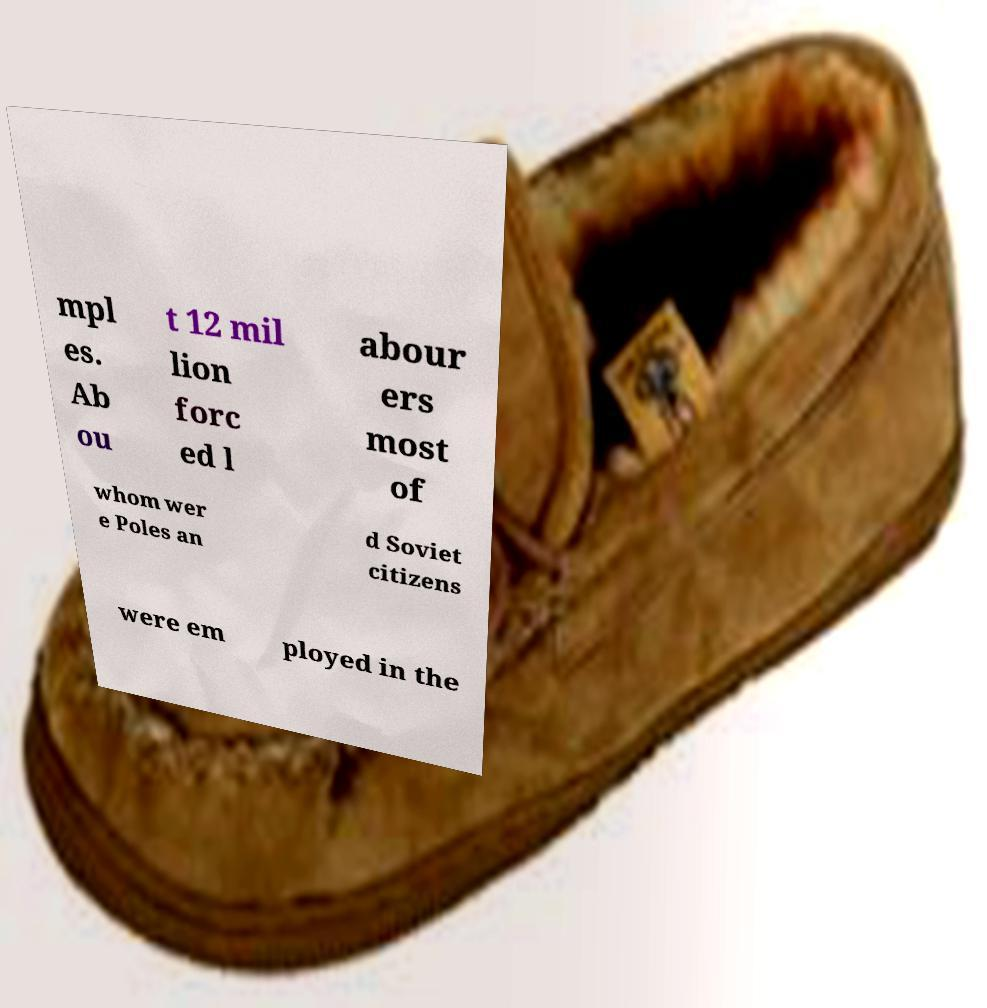What messages or text are displayed in this image? I need them in a readable, typed format. mpl es. Ab ou t 12 mil lion forc ed l abour ers most of whom wer e Poles an d Soviet citizens were em ployed in the 